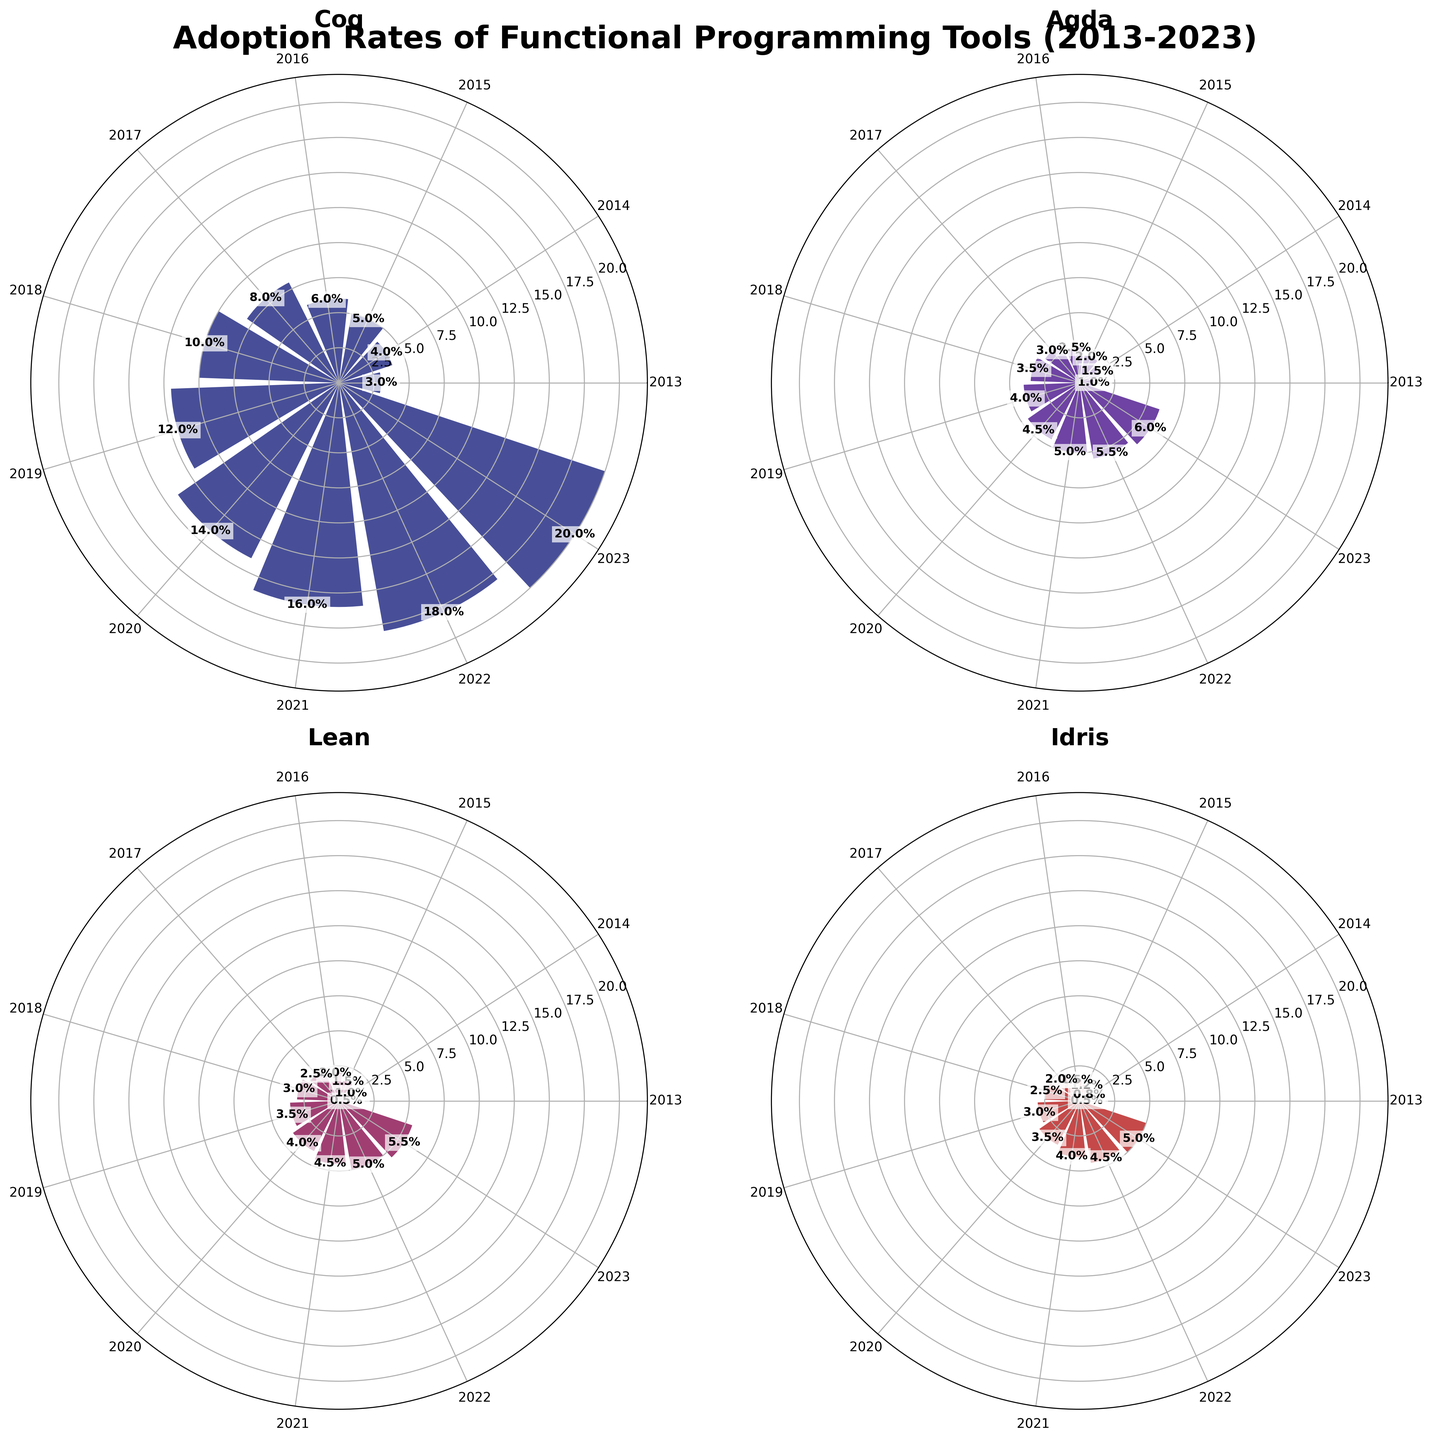How many functional programming tools are displayed in the figure? The figure has subplots for four distinct functional programming tools each with its polar chart representation.
Answer: Four What is the title of the figure? The title is displayed at the top center of the figure and reads: "Adoption Rates of Functional Programming Tools (2013-2023)".
Answer: Adoption Rates of Functional Programming Tools (2013-2023) In 2013, which tool had the lowest adoption rate? The polar chart for each tool shows the adoption rates for each year. In 2013, Lean and Idris both had the lowest adoption rate at 0.5%.
Answer: Lean and Idris By how much did Coq's adoption rate increase from 2013 to 2023? Referring to Coq's subplot, the adoption rate in 2013 was 3%, and it increased to 20% in 2023. The increase can be computed as 20% - 3% = 17%.
Answer: 17% Which tool had the highest adoption rate in 2020? By examining the polar charts, Coq had the highest adoption rate in 2020 at 14%.
Answer: Coq What was the average adoption rate for Agda across all years? To calculate the average, sum all adoption rates for Agda from 2013 to 2023 and divide by the number of years: (1 + 1.5 + 2 + 2.5 + 3 + 3.5 + 4 + 4.5 + 5 + 5.5 + 6) / 11 = 3.77%
Answer: 3.77% In which year did Lean have an adoption rate of 4%? By checking Lean's subplot, we see that Lean reached an adoption rate of 4% in 2020.
Answer: 2020 Between which consecutive years did Idris see the largest increase in adoption rate? Examining Idris's subplot, the largest increase is between 2013 (0.5%) and 2014 (0.8%), which is an increase of 0.8% - 0.5% = 0.3%. From any other pair of consecutive years, the increase is smaller than 0.3%.
Answer: 2013 and 2014 What was the difference in adoption rates between Agda and Lean in 2023? In 2023, Agda had an adoption rate of 6%, while Lean had 5.5%. The difference is calculated as 6% - 5.5% = 0.5%.
Answer: 0.5% Which tool shows continuous year-on-year increase in adoption rates from 2013 to 2023? By examining each tool's subplot, it is seen that Coq's adoption rate consistently increases every year from 2013 (3%) to 2023 (20%).
Answer: Coq 